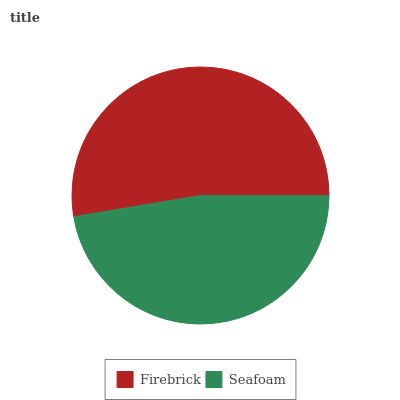Is Seafoam the minimum?
Answer yes or no. Yes. Is Firebrick the maximum?
Answer yes or no. Yes. Is Seafoam the maximum?
Answer yes or no. No. Is Firebrick greater than Seafoam?
Answer yes or no. Yes. Is Seafoam less than Firebrick?
Answer yes or no. Yes. Is Seafoam greater than Firebrick?
Answer yes or no. No. Is Firebrick less than Seafoam?
Answer yes or no. No. Is Firebrick the high median?
Answer yes or no. Yes. Is Seafoam the low median?
Answer yes or no. Yes. Is Seafoam the high median?
Answer yes or no. No. Is Firebrick the low median?
Answer yes or no. No. 